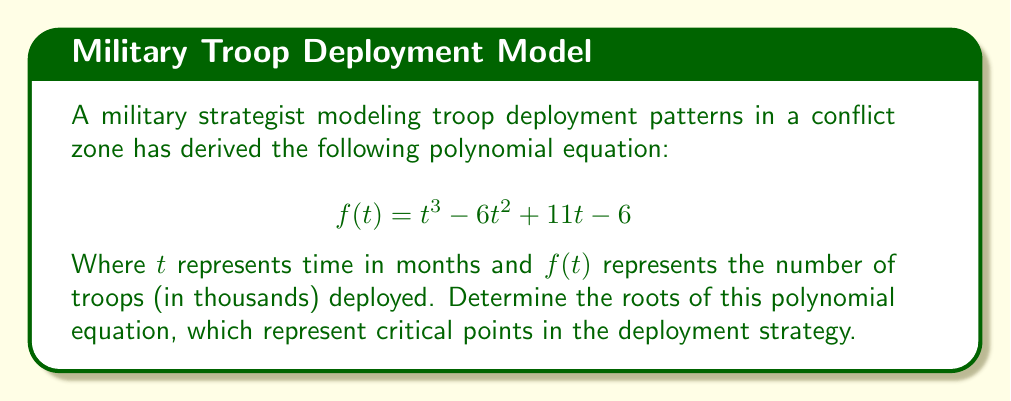Can you answer this question? To find the roots of this polynomial, we need to factor the equation $f(t) = t^3 - 6t^2 + 11t - 6$. Let's approach this step-by-step:

1) First, let's check if there are any rational roots using the rational root theorem. The possible rational roots are the factors of the constant term (6): ±1, ±2, ±3, ±6.

2) Testing these values, we find that $f(1) = 0$. So, $(t-1)$ is a factor.

3) We can use polynomial long division to divide $f(t)$ by $(t-1)$:

   $$
   t^2 - 5t + 6 \
   t - 1 \enclose{longdiv}{t^3 - 6t^2 + 11t - 6}
   $$

4) The result of this division is $t^2 - 5t + 6$, so we have:

   $$f(t) = (t-1)(t^2 - 5t + 6)$$

5) Now we need to factor $t^2 - 5t + 6$. This is a quadratic equation, so we can use the quadratic formula or factoring by grouping.

6) The quadratic formula gives us:
   
   $$t = \frac{5 \pm \sqrt{25 - 24}}{2} = \frac{5 \pm 1}{2}$$

7) So, the other two factors are $(t-2)$ and $(t-3)$.

Therefore, the fully factored polynomial is:

$$f(t) = (t-1)(t-2)(t-3)$$

The roots are thus $t = 1$, $t = 2$, and $t = 3$.
Answer: The roots of the polynomial equation are 1, 2, and 3. 